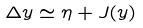Convert formula to latex. <formula><loc_0><loc_0><loc_500><loc_500>\Delta y \simeq \eta + J ( y )</formula> 